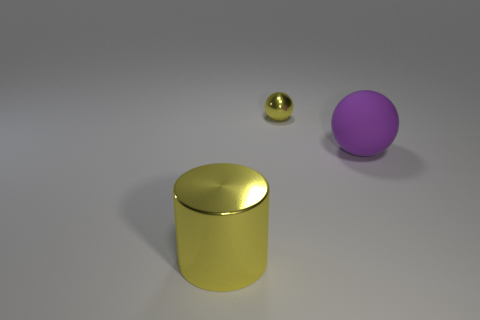Is there any other thing that has the same material as the purple object?
Provide a short and direct response. No. What is the color of the thing that is both behind the large yellow thing and in front of the small sphere?
Your response must be concise. Purple. Is there any other thing of the same color as the matte ball?
Your answer should be compact. No. There is a metallic object behind the ball in front of the tiny yellow thing; what color is it?
Your answer should be compact. Yellow. Does the shiny cylinder have the same size as the rubber object?
Give a very brief answer. Yes. Is the material of the yellow object left of the tiny metallic thing the same as the thing behind the purple ball?
Your answer should be very brief. Yes. The big thing to the left of the large object that is on the right side of the shiny object that is in front of the tiny yellow ball is what shape?
Your answer should be very brief. Cylinder. Are there more small yellow metal things than small blue matte balls?
Provide a succinct answer. Yes. Are any yellow things visible?
Ensure brevity in your answer.  Yes. How many things are either metal things behind the large purple thing or yellow things behind the large ball?
Your answer should be compact. 1. 